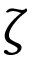Convert formula to latex. <formula><loc_0><loc_0><loc_500><loc_500>\zeta</formula> 